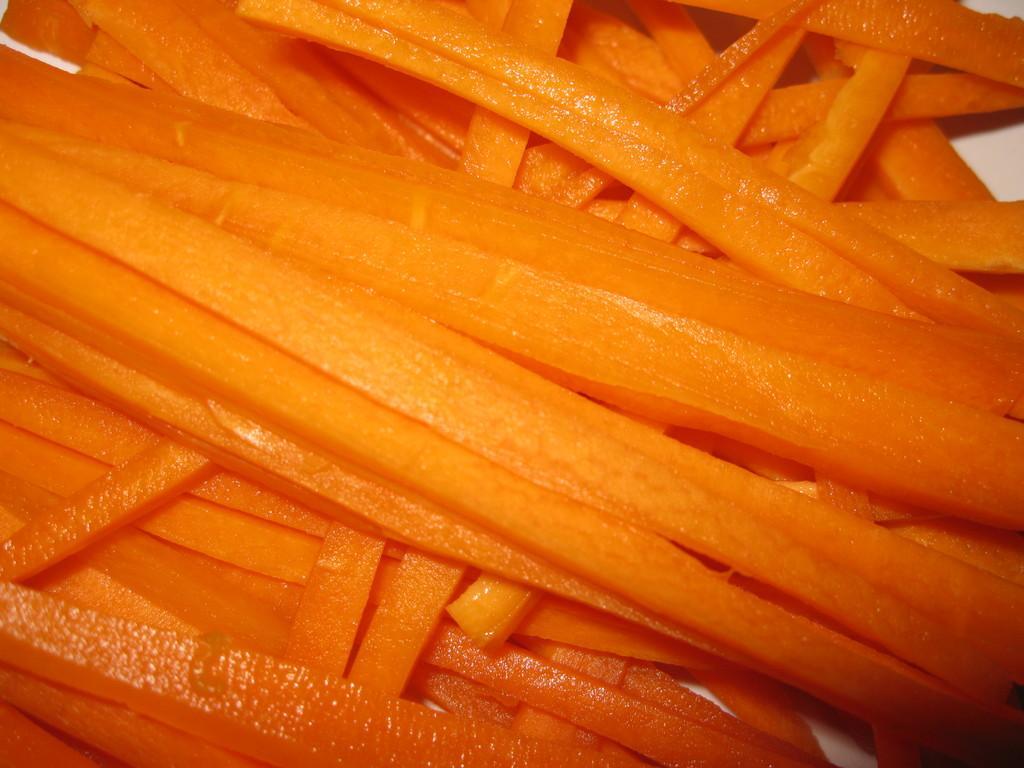Could you give a brief overview of what you see in this image? In this picture there are carrot slices. At the bottom it looks like a plate. 